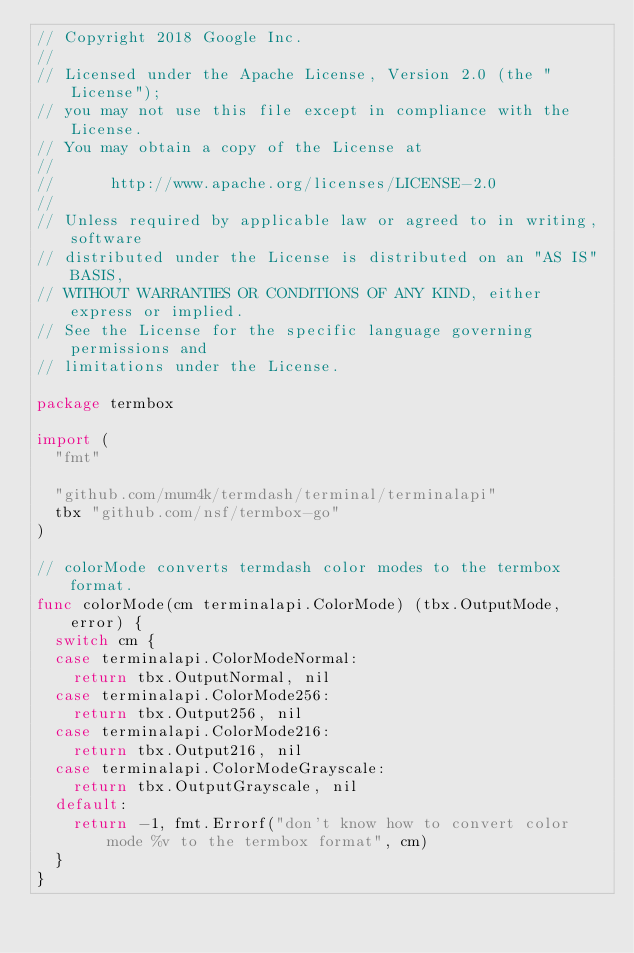<code> <loc_0><loc_0><loc_500><loc_500><_Go_>// Copyright 2018 Google Inc.
//
// Licensed under the Apache License, Version 2.0 (the "License");
// you may not use this file except in compliance with the License.
// You may obtain a copy of the License at
//
//      http://www.apache.org/licenses/LICENSE-2.0
//
// Unless required by applicable law or agreed to in writing, software
// distributed under the License is distributed on an "AS IS" BASIS,
// WITHOUT WARRANTIES OR CONDITIONS OF ANY KIND, either express or implied.
// See the License for the specific language governing permissions and
// limitations under the License.

package termbox

import (
	"fmt"

	"github.com/mum4k/termdash/terminal/terminalapi"
	tbx "github.com/nsf/termbox-go"
)

// colorMode converts termdash color modes to the termbox format.
func colorMode(cm terminalapi.ColorMode) (tbx.OutputMode, error) {
	switch cm {
	case terminalapi.ColorModeNormal:
		return tbx.OutputNormal, nil
	case terminalapi.ColorMode256:
		return tbx.Output256, nil
	case terminalapi.ColorMode216:
		return tbx.Output216, nil
	case terminalapi.ColorModeGrayscale:
		return tbx.OutputGrayscale, nil
	default:
		return -1, fmt.Errorf("don't know how to convert color mode %v to the termbox format", cm)
	}
}
</code> 